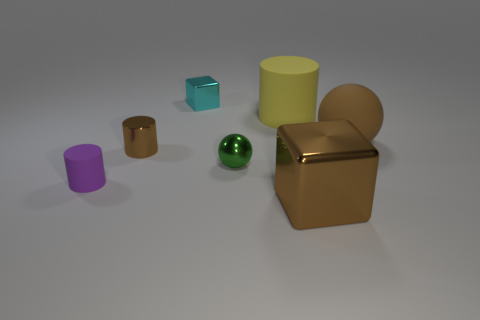Add 1 big metallic things. How many objects exist? 8 Subtract all spheres. How many objects are left? 5 Add 2 yellow cylinders. How many yellow cylinders exist? 3 Subtract 0 gray cylinders. How many objects are left? 7 Subtract all small blue metal balls. Subtract all green shiny balls. How many objects are left? 6 Add 3 large brown metallic objects. How many large brown metallic objects are left? 4 